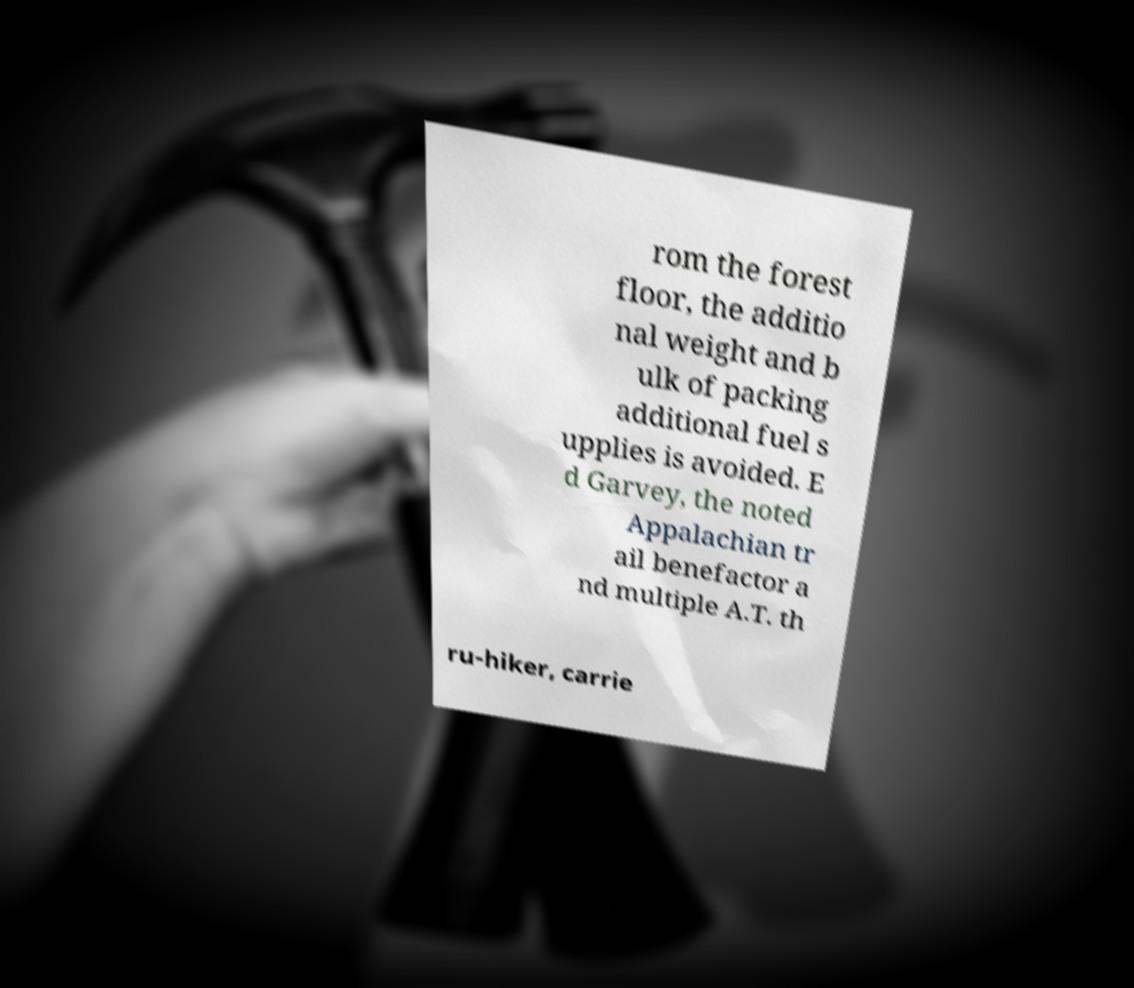Can you read and provide the text displayed in the image?This photo seems to have some interesting text. Can you extract and type it out for me? rom the forest floor, the additio nal weight and b ulk of packing additional fuel s upplies is avoided. E d Garvey, the noted Appalachian tr ail benefactor a nd multiple A.T. th ru-hiker, carrie 